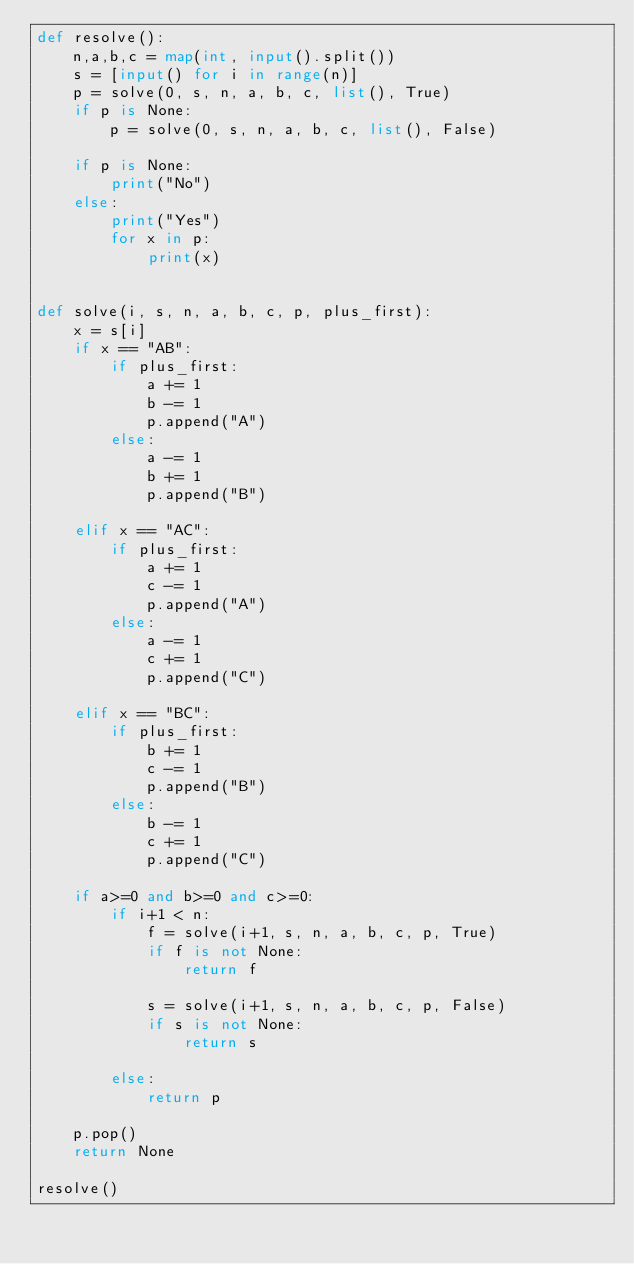Convert code to text. <code><loc_0><loc_0><loc_500><loc_500><_Python_>def resolve():
    n,a,b,c = map(int, input().split())
    s = [input() for i in range(n)]
    p = solve(0, s, n, a, b, c, list(), True)
    if p is None:
        p = solve(0, s, n, a, b, c, list(), False)
    
    if p is None:
        print("No")
    else:
        print("Yes")
        for x in p:
            print(x)


def solve(i, s, n, a, b, c, p, plus_first):
    x = s[i]
    if x == "AB":
        if plus_first:
            a += 1
            b -= 1
            p.append("A")
        else:
            a -= 1
            b += 1
            p.append("B")

    elif x == "AC":
        if plus_first:
            a += 1
            c -= 1
            p.append("A")
        else:
            a -= 1
            c += 1
            p.append("C")

    elif x == "BC":
        if plus_first:
            b += 1
            c -= 1
            p.append("B")
        else:
            b -= 1
            c += 1
            p.append("C")

    if a>=0 and b>=0 and c>=0:
        if i+1 < n:
            f = solve(i+1, s, n, a, b, c, p, True)
            if f is not None:
                return f
            
            s = solve(i+1, s, n, a, b, c, p, False)
            if s is not None: 
                return s

        else:
            return p

    p.pop()
    return None

resolve()</code> 